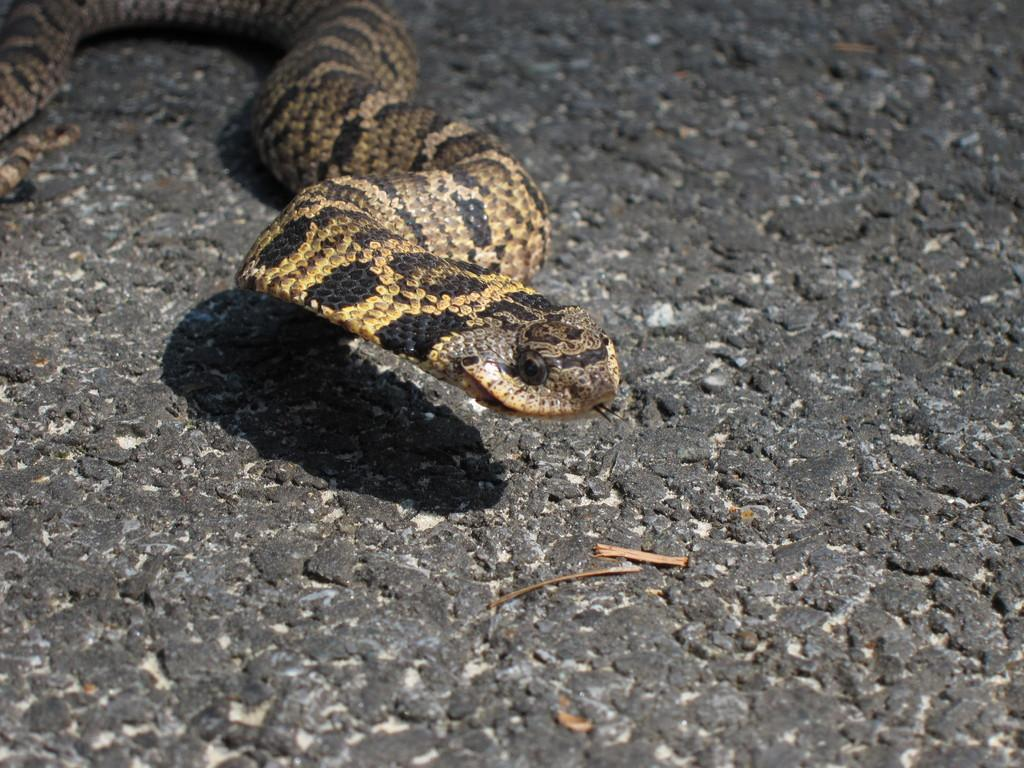What type of surface is visible in the image? There is a rock surface in the image. What animal can be seen on the rock surface? There is a snake in the image. What is the color of the snake? The snake is cream in color. Are there any additional markings on the snake? Yes, the snake has black color dots on it. What type of bushes can be seen near the seashore in the image? There is no mention of bushes or a seashore in the image; it features a rock surface with a cream-colored snake that has black color dots on it. Can you tell me how many balloons are floating above the snake in the image? There are no balloons present in the image. 